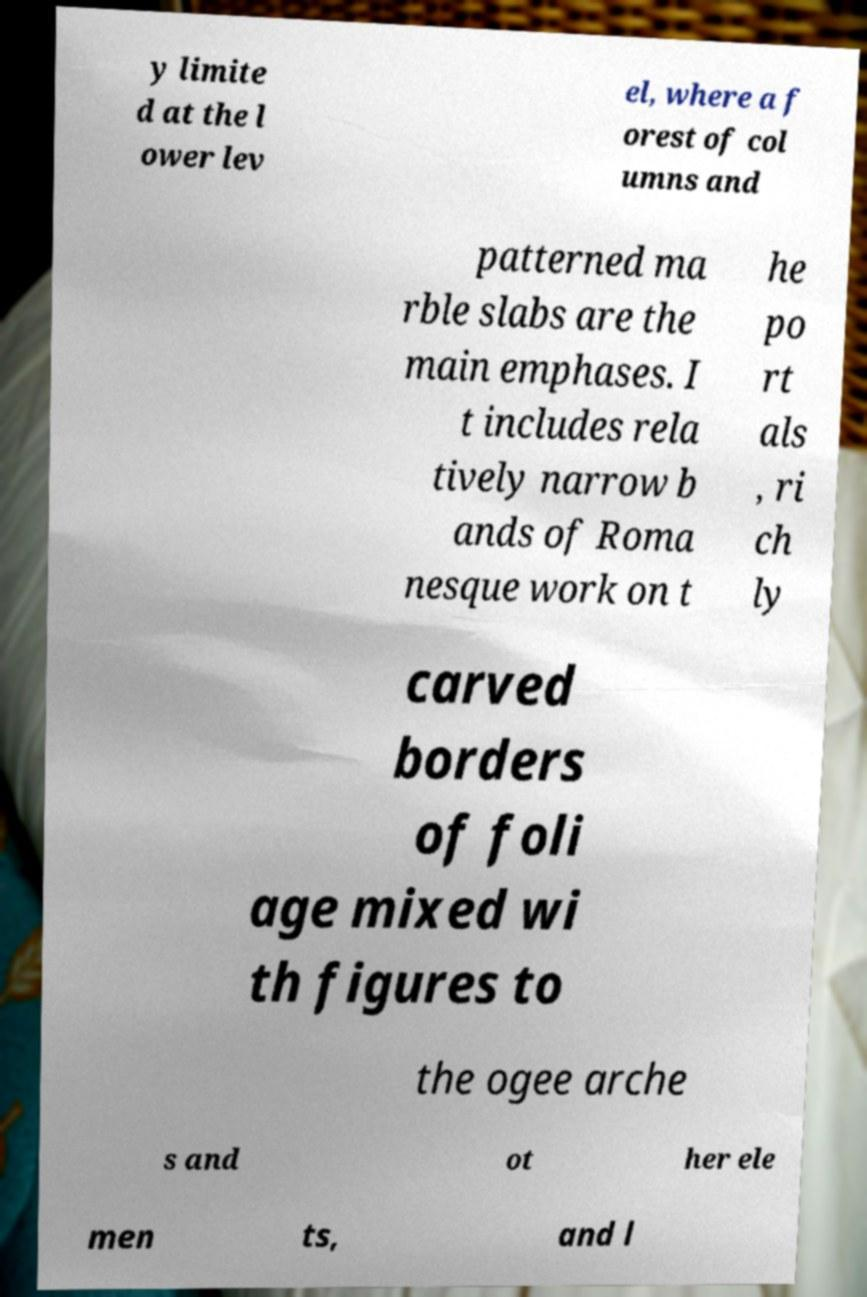Please read and relay the text visible in this image. What does it say? y limite d at the l ower lev el, where a f orest of col umns and patterned ma rble slabs are the main emphases. I t includes rela tively narrow b ands of Roma nesque work on t he po rt als , ri ch ly carved borders of foli age mixed wi th figures to the ogee arche s and ot her ele men ts, and l 